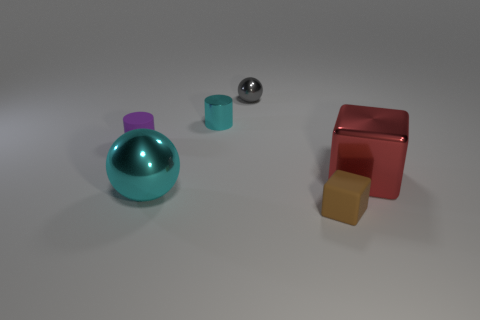What is the material of the big thing that is the same color as the tiny metallic cylinder?
Your response must be concise. Metal. Are there any matte blocks to the left of the matte thing in front of the tiny purple rubber cylinder?
Offer a very short reply. No. There is a tiny brown object; what number of gray shiny things are in front of it?
Offer a terse response. 0. What number of other things are the same color as the rubber cylinder?
Offer a very short reply. 0. Is the number of large cyan objects behind the small metal sphere less than the number of tiny gray shiny things that are in front of the brown object?
Provide a short and direct response. No. What number of things are either cyan metal objects that are in front of the big red metallic cube or blue spheres?
Keep it short and to the point. 1. There is a red shiny cube; is its size the same as the sphere in front of the metal cube?
Provide a succinct answer. Yes. There is a cyan metal object that is the same shape as the gray thing; what size is it?
Your answer should be compact. Large. What number of spheres are behind the metallic thing to the right of the small gray object that is to the right of the tiny purple rubber cylinder?
Offer a terse response. 1. How many balls are either purple matte things or brown things?
Give a very brief answer. 0. 